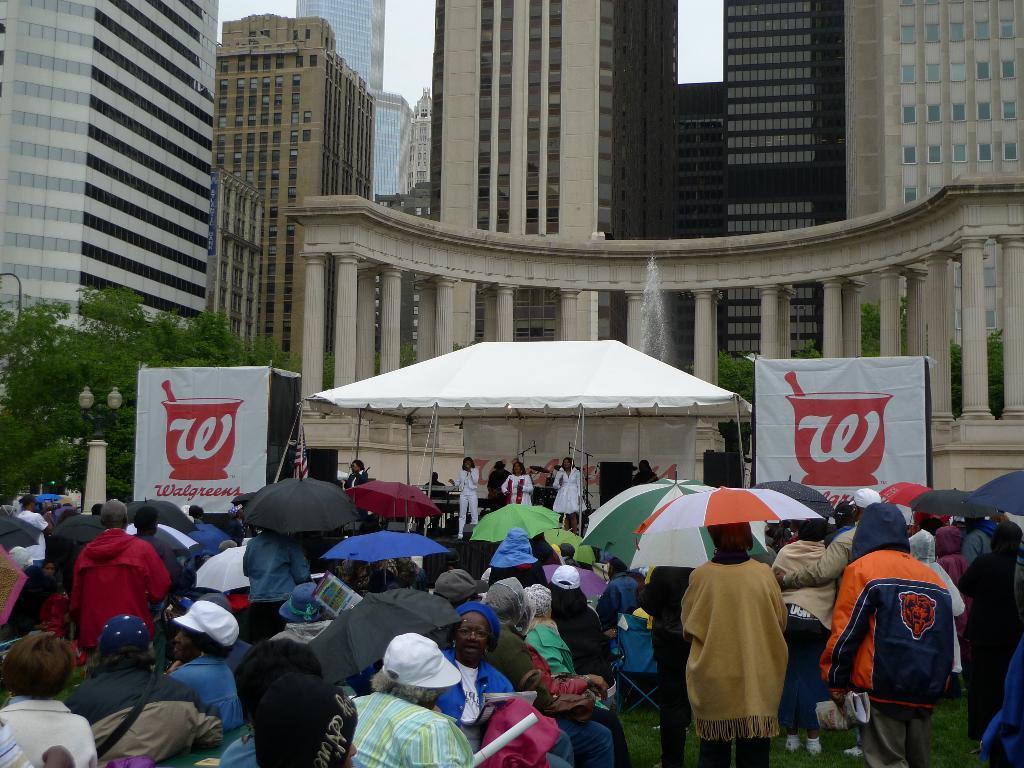Describe this image in one or two sentences. At the bottom of the image we can see persons and umbrellas. In the center of the image we can see persons performing on days under the tent. In the background we can see pillars, water fountain, buildings, trees and sky. 